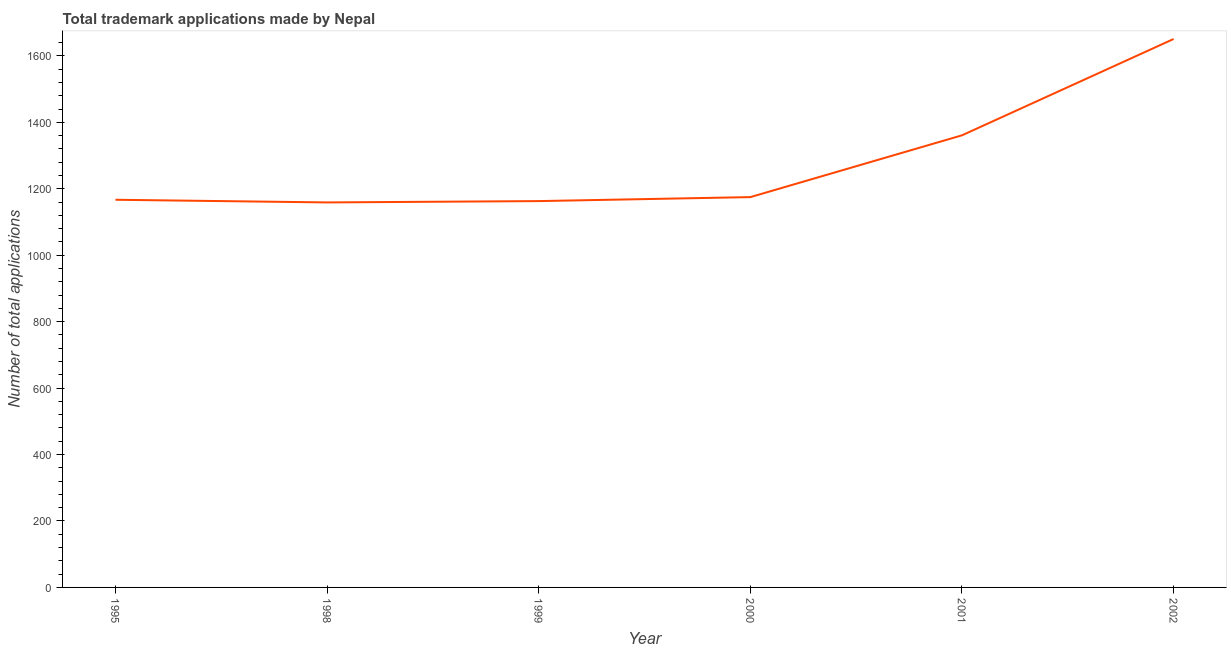What is the number of trademark applications in 2001?
Keep it short and to the point. 1361. Across all years, what is the maximum number of trademark applications?
Make the answer very short. 1651. Across all years, what is the minimum number of trademark applications?
Your answer should be very brief. 1159. In which year was the number of trademark applications maximum?
Your answer should be compact. 2002. In which year was the number of trademark applications minimum?
Your response must be concise. 1998. What is the sum of the number of trademark applications?
Give a very brief answer. 7676. What is the difference between the number of trademark applications in 1999 and 2000?
Ensure brevity in your answer.  -12. What is the average number of trademark applications per year?
Make the answer very short. 1279.33. What is the median number of trademark applications?
Your response must be concise. 1171. Do a majority of the years between 1998 and 2000 (inclusive) have number of trademark applications greater than 760 ?
Offer a terse response. Yes. What is the ratio of the number of trademark applications in 1998 to that in 1999?
Offer a very short reply. 1. Is the number of trademark applications in 2001 less than that in 2002?
Your answer should be compact. Yes. Is the difference between the number of trademark applications in 1995 and 1999 greater than the difference between any two years?
Ensure brevity in your answer.  No. What is the difference between the highest and the second highest number of trademark applications?
Your response must be concise. 290. Is the sum of the number of trademark applications in 2000 and 2002 greater than the maximum number of trademark applications across all years?
Make the answer very short. Yes. What is the difference between the highest and the lowest number of trademark applications?
Your answer should be compact. 492. In how many years, is the number of trademark applications greater than the average number of trademark applications taken over all years?
Provide a short and direct response. 2. Does the number of trademark applications monotonically increase over the years?
Offer a very short reply. No. How many years are there in the graph?
Ensure brevity in your answer.  6. What is the difference between two consecutive major ticks on the Y-axis?
Ensure brevity in your answer.  200. Does the graph contain any zero values?
Provide a succinct answer. No. Does the graph contain grids?
Make the answer very short. No. What is the title of the graph?
Give a very brief answer. Total trademark applications made by Nepal. What is the label or title of the X-axis?
Provide a succinct answer. Year. What is the label or title of the Y-axis?
Offer a terse response. Number of total applications. What is the Number of total applications in 1995?
Make the answer very short. 1167. What is the Number of total applications in 1998?
Give a very brief answer. 1159. What is the Number of total applications in 1999?
Provide a succinct answer. 1163. What is the Number of total applications of 2000?
Offer a very short reply. 1175. What is the Number of total applications of 2001?
Keep it short and to the point. 1361. What is the Number of total applications in 2002?
Ensure brevity in your answer.  1651. What is the difference between the Number of total applications in 1995 and 2001?
Ensure brevity in your answer.  -194. What is the difference between the Number of total applications in 1995 and 2002?
Provide a succinct answer. -484. What is the difference between the Number of total applications in 1998 and 1999?
Offer a terse response. -4. What is the difference between the Number of total applications in 1998 and 2000?
Ensure brevity in your answer.  -16. What is the difference between the Number of total applications in 1998 and 2001?
Provide a short and direct response. -202. What is the difference between the Number of total applications in 1998 and 2002?
Your answer should be compact. -492. What is the difference between the Number of total applications in 1999 and 2001?
Make the answer very short. -198. What is the difference between the Number of total applications in 1999 and 2002?
Offer a terse response. -488. What is the difference between the Number of total applications in 2000 and 2001?
Make the answer very short. -186. What is the difference between the Number of total applications in 2000 and 2002?
Make the answer very short. -476. What is the difference between the Number of total applications in 2001 and 2002?
Offer a terse response. -290. What is the ratio of the Number of total applications in 1995 to that in 1998?
Provide a short and direct response. 1.01. What is the ratio of the Number of total applications in 1995 to that in 2001?
Offer a terse response. 0.86. What is the ratio of the Number of total applications in 1995 to that in 2002?
Make the answer very short. 0.71. What is the ratio of the Number of total applications in 1998 to that in 1999?
Provide a succinct answer. 1. What is the ratio of the Number of total applications in 1998 to that in 2001?
Keep it short and to the point. 0.85. What is the ratio of the Number of total applications in 1998 to that in 2002?
Provide a short and direct response. 0.7. What is the ratio of the Number of total applications in 1999 to that in 2000?
Offer a terse response. 0.99. What is the ratio of the Number of total applications in 1999 to that in 2001?
Your answer should be very brief. 0.85. What is the ratio of the Number of total applications in 1999 to that in 2002?
Your answer should be very brief. 0.7. What is the ratio of the Number of total applications in 2000 to that in 2001?
Offer a very short reply. 0.86. What is the ratio of the Number of total applications in 2000 to that in 2002?
Make the answer very short. 0.71. What is the ratio of the Number of total applications in 2001 to that in 2002?
Your response must be concise. 0.82. 